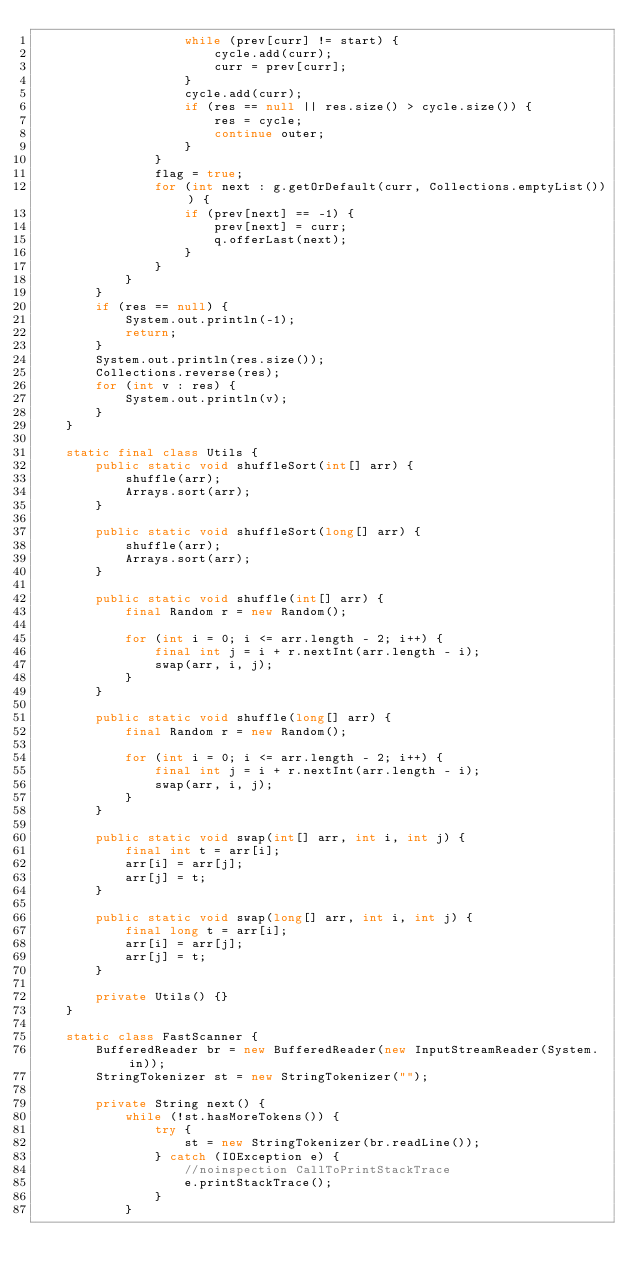<code> <loc_0><loc_0><loc_500><loc_500><_Java_>                    while (prev[curr] != start) {
                        cycle.add(curr);
                        curr = prev[curr];
                    }
                    cycle.add(curr);
                    if (res == null || res.size() > cycle.size()) {
                        res = cycle;
                        continue outer;
                    }
                }
                flag = true;
                for (int next : g.getOrDefault(curr, Collections.emptyList())) {
                    if (prev[next] == -1) {
                        prev[next] = curr;
                        q.offerLast(next);
                    }
                }
            }
        }
        if (res == null) {
            System.out.println(-1);
            return;
        }
        System.out.println(res.size());
        Collections.reverse(res);
        for (int v : res) {
            System.out.println(v);
        }
    }

    static final class Utils {
        public static void shuffleSort(int[] arr) {
            shuffle(arr);
            Arrays.sort(arr);
        }

        public static void shuffleSort(long[] arr) {
            shuffle(arr);
            Arrays.sort(arr);
        }

        public static void shuffle(int[] arr) {
            final Random r = new Random();

            for (int i = 0; i <= arr.length - 2; i++) {
                final int j = i + r.nextInt(arr.length - i);
                swap(arr, i, j);
            }
        }

        public static void shuffle(long[] arr) {
            final Random r = new Random();

            for (int i = 0; i <= arr.length - 2; i++) {
                final int j = i + r.nextInt(arr.length - i);
                swap(arr, i, j);
            }
        }

        public static void swap(int[] arr, int i, int j) {
            final int t = arr[i];
            arr[i] = arr[j];
            arr[j] = t;
        }

        public static void swap(long[] arr, int i, int j) {
            final long t = arr[i];
            arr[i] = arr[j];
            arr[j] = t;
        }

        private Utils() {}
    }

    static class FastScanner {
        BufferedReader br = new BufferedReader(new InputStreamReader(System.in));
        StringTokenizer st = new StringTokenizer("");

        private String next() {
            while (!st.hasMoreTokens()) {
                try {
                    st = new StringTokenizer(br.readLine());
                } catch (IOException e) {
                    //noinspection CallToPrintStackTrace
                    e.printStackTrace();
                }
            }</code> 